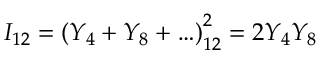Convert formula to latex. <formula><loc_0><loc_0><loc_500><loc_500>I _ { 1 2 } = \left ( Y _ { 4 } + Y _ { 8 } + \dots \right ) _ { 1 2 } ^ { 2 } = 2 Y _ { 4 } Y _ { 8 }</formula> 